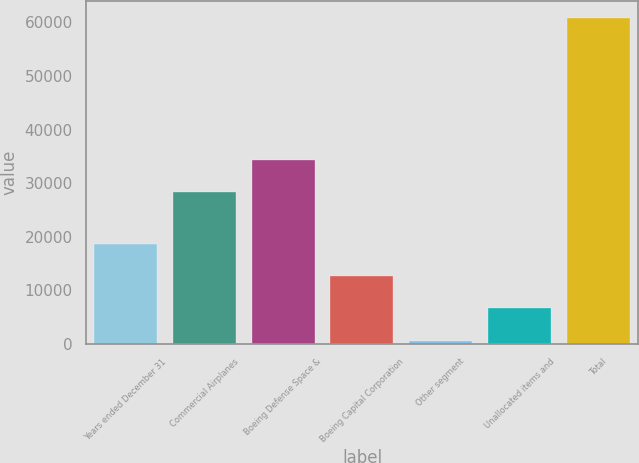Convert chart. <chart><loc_0><loc_0><loc_500><loc_500><bar_chart><fcel>Years ended December 31<fcel>Commercial Airplanes<fcel>Boeing Defense Space &<fcel>Boeing Capital Corporation<fcel>Other segment<fcel>Unallocated items and<fcel>Total<nl><fcel>18669.6<fcel>28263<fcel>34297.2<fcel>12635.4<fcel>567<fcel>6601.2<fcel>60909<nl></chart> 